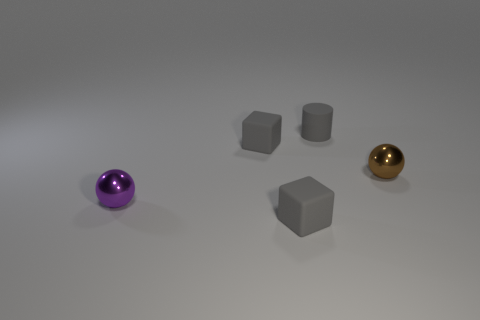Are there fewer small shiny balls in front of the purple metal ball than tiny gray objects that are behind the brown metallic thing?
Keep it short and to the point. Yes. There is a rubber object that is behind the purple ball and in front of the tiny cylinder; what shape is it?
Your response must be concise. Cube. Is the color of the small rubber cylinder the same as the cube behind the small purple ball?
Your answer should be very brief. Yes. The tiny object that is both behind the small brown thing and in front of the rubber cylinder is made of what material?
Your response must be concise. Rubber. There is a tiny gray object that is in front of the tiny brown metallic sphere; is it the same shape as the metallic thing that is on the left side of the gray matte cylinder?
Your answer should be compact. No. Is there a sphere?
Your answer should be very brief. Yes. The other small object that is the same shape as the brown object is what color?
Your answer should be very brief. Purple. There is a cylinder that is the same size as the purple shiny object; what color is it?
Offer a very short reply. Gray. Do the brown object and the cylinder have the same material?
Provide a short and direct response. No. How many tiny rubber objects have the same color as the matte cylinder?
Give a very brief answer. 2. 